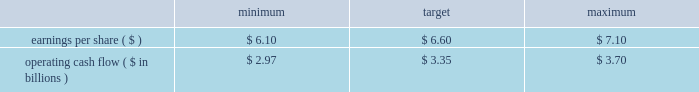The target awards for the other named executive officers were set as follows : joseph f .
Domino , ceo - entergy texas ( 50% ( 50 % ) ) ; hugh t .
Mcdonald , ceo - entergy arkansas ( 50% ( 50 % ) ) ; haley fisackerly , ceo - entergy mississippi ( 40% ( 40 % ) ) ; william m .
Mohl ( 60% ( 60 % ) ) , ceo - entergy gulf states and entergy louisiana ; charles l .
Rice , jr .
( 40% ( 40 % ) ) , ceo - entergy new orleans and theodore h .
Bunting , jr .
- principal accounting officer - the subsidiaries ( 60% ( 60 % ) ) .
The target awards for the named executive officers ( other than entergy named executive officers ) were set by their respective supervisors ( subject to ultimate approval of entergy 2019s chief executive officer ) who allocated a potential incentive pool established by the personnel committee among various of their direct and indirect reports .
In setting the target awards , the supervisor took into account considerations similar to those used by the personnel committee in setting the target awards for entergy 2019s named executive officers .
Target awards are set based on an executive officer 2019s current position and executive management level within the entergy organization .
Executive management levels at entergy range from level 1 thorough level 4 .
Mr .
Denault and mr .
Taylor hold positions in level 2 whereas mr .
Bunting and mr .
Mohl hold positions in level 3 and mr .
Domino , mr .
Fisackerly , mr .
Mcdonald and mr .
Rice hold positions in level 4 .
Accordingly , their respective incentive targets differ one from another based on the external market data developed by the committee 2019s independent compensation consultant and the other factors noted above .
In december 2010 , the committee determined the executive incentive plan targets to be used for purposes of establishing annual bonuses for 2011 .
The committee 2019s determination of the target levels was made after full board review of management 2019s 2011 financial plan for entergy corporation , upon recommendation of the finance committee , and after the committee 2019s determination that the established targets aligned with entergy corporation 2019s anticipated 2011 financial performance as reflected in the financial plan .
The targets established to measure management performance against as reported results were: .
Operating cash flow ( $ in billions ) in january 2012 , after reviewing earnings per share and operating cash flow results against the performance objectives in the above table , the committee determined that entergy corporation had exceeded as reported earnings per share target of $ 6.60 by $ 0.95 in 2011 while falling short of the operating cash flow goal of $ 3.35 billion by $ 221 million in 2011 .
In accordance with the terms of the annual incentive plan , in january 2012 , the personnel committee certified the 2012 entergy achievement multiplier at 128% ( 128 % ) of target .
Under the terms of the management effectiveness program , the entergy achievement multiplier is automatically increased by 25 percent for the members of the office of the chief executive if the pre- established underlying performance goals established by the personnel committee are satisfied at the end of the performance period , subject to the personnel committee's discretion to adjust the automatic multiplier downward or eliminate it altogether .
In accordance with section 162 ( m ) of the internal revenue code , the multiplier which entergy refers to as the management effectiveness factor is intended to provide the committee a mechanism to take into consideration specific achievement factors relating to the overall performance of entergy corporation .
In january 2012 , the committee eliminated the management effectiveness factor with respect to the 2011 incentive awards , reflecting the personnel committee's determination that the entergy achievement multiplier , in and of itself without the management effectiveness factor , was consistent with the performance levels achieved by management .
The annual incentive awards for the named executive officers ( other than mr .
Leonard , mr .
Denault and mr .
Taylor ) are awarded from an incentive pool approved by the committee .
From this pool , each named executive officer 2019s supervisor determines the annual incentive payment based on the entergy achievement multiplier .
The supervisor has the discretion to increase or decrease the multiple used to determine an incentive award based on individual and business unit performance .
The incentive awards are subject to the ultimate approval of entergy 2019s chief executive officer. .
What is actual operating cash flow reported for 2011? 
Computations: (3.35 - (221 / 1000000))
Answer: 3.34978. 